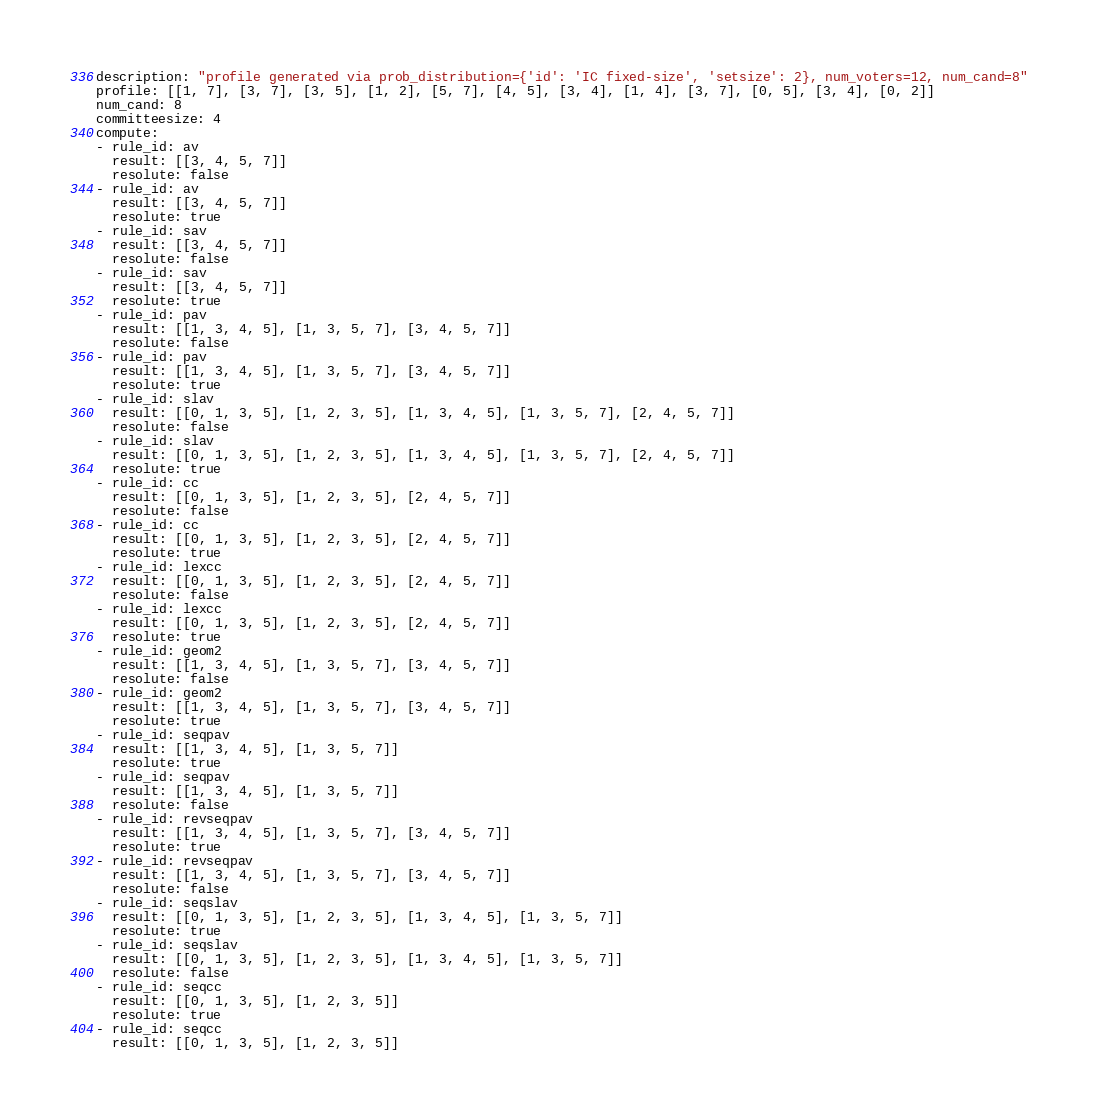Convert code to text. <code><loc_0><loc_0><loc_500><loc_500><_YAML_>description: "profile generated via prob_distribution={'id': 'IC fixed-size', 'setsize': 2}, num_voters=12, num_cand=8"
profile: [[1, 7], [3, 7], [3, 5], [1, 2], [5, 7], [4, 5], [3, 4], [1, 4], [3, 7], [0, 5], [3, 4], [0, 2]]
num_cand: 8
committeesize: 4
compute:
- rule_id: av
  result: [[3, 4, 5, 7]]
  resolute: false
- rule_id: av
  result: [[3, 4, 5, 7]]
  resolute: true
- rule_id: sav
  result: [[3, 4, 5, 7]]
  resolute: false
- rule_id: sav
  result: [[3, 4, 5, 7]]
  resolute: true
- rule_id: pav
  result: [[1, 3, 4, 5], [1, 3, 5, 7], [3, 4, 5, 7]]
  resolute: false
- rule_id: pav
  result: [[1, 3, 4, 5], [1, 3, 5, 7], [3, 4, 5, 7]]
  resolute: true
- rule_id: slav
  result: [[0, 1, 3, 5], [1, 2, 3, 5], [1, 3, 4, 5], [1, 3, 5, 7], [2, 4, 5, 7]]
  resolute: false
- rule_id: slav
  result: [[0, 1, 3, 5], [1, 2, 3, 5], [1, 3, 4, 5], [1, 3, 5, 7], [2, 4, 5, 7]]
  resolute: true
- rule_id: cc
  result: [[0, 1, 3, 5], [1, 2, 3, 5], [2, 4, 5, 7]]
  resolute: false
- rule_id: cc
  result: [[0, 1, 3, 5], [1, 2, 3, 5], [2, 4, 5, 7]]
  resolute: true
- rule_id: lexcc
  result: [[0, 1, 3, 5], [1, 2, 3, 5], [2, 4, 5, 7]]
  resolute: false
- rule_id: lexcc
  result: [[0, 1, 3, 5], [1, 2, 3, 5], [2, 4, 5, 7]]
  resolute: true
- rule_id: geom2
  result: [[1, 3, 4, 5], [1, 3, 5, 7], [3, 4, 5, 7]]
  resolute: false
- rule_id: geom2
  result: [[1, 3, 4, 5], [1, 3, 5, 7], [3, 4, 5, 7]]
  resolute: true
- rule_id: seqpav
  result: [[1, 3, 4, 5], [1, 3, 5, 7]]
  resolute: true
- rule_id: seqpav
  result: [[1, 3, 4, 5], [1, 3, 5, 7]]
  resolute: false
- rule_id: revseqpav
  result: [[1, 3, 4, 5], [1, 3, 5, 7], [3, 4, 5, 7]]
  resolute: true
- rule_id: revseqpav
  result: [[1, 3, 4, 5], [1, 3, 5, 7], [3, 4, 5, 7]]
  resolute: false
- rule_id: seqslav
  result: [[0, 1, 3, 5], [1, 2, 3, 5], [1, 3, 4, 5], [1, 3, 5, 7]]
  resolute: true
- rule_id: seqslav
  result: [[0, 1, 3, 5], [1, 2, 3, 5], [1, 3, 4, 5], [1, 3, 5, 7]]
  resolute: false
- rule_id: seqcc
  result: [[0, 1, 3, 5], [1, 2, 3, 5]]
  resolute: true
- rule_id: seqcc
  result: [[0, 1, 3, 5], [1, 2, 3, 5]]</code> 